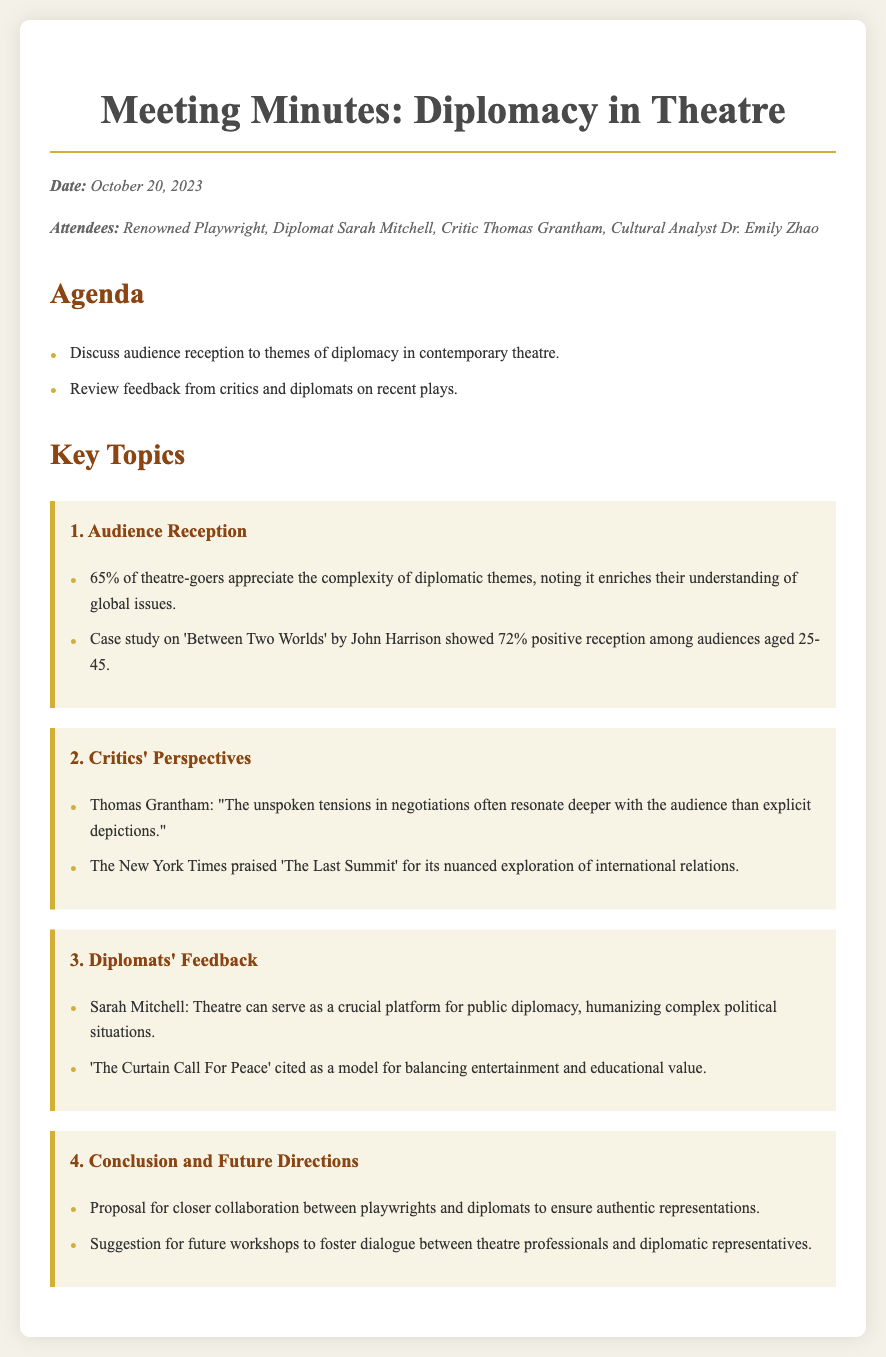what was the date of the meeting? The date of the meeting is explicitly stated in the document.
Answer: October 20, 2023 who is the cultural analyst attending the meeting? The role of cultural analyst is filled by one of the attendees as mentioned in the document.
Answer: Dr. Emily Zhao what percentage of theatre-goers appreciate the complexity of diplomatic themes? This figure is provided in the audience reception section of the document.
Answer: 65% who cited 'The Curtain Call For Peace' as a model? This individual is explicitly mentioned in the diplomats' feedback section of the document.
Answer: Sarah Mitchell what is the positive reception percentage for 'Between Two Worlds'? This statistic is provided in the audience reception section and refers to audience feedback on the play.
Answer: 72% what was proposed for future collaboration? This proposal is mentioned in the conclusion and future directions section of the document.
Answer: Closer collaboration between playwrights and diplomats what did Thomas Grantham mention in the critics' perspectives? This statement is a specific quote provided in the critics' perspectives section of the document.
Answer: "The unspoken tensions in negotiations often resonate deeper with the audience than explicit depictions." how many attendees were at the meeting? The document lists the attendees at the meeting.
Answer: Four 